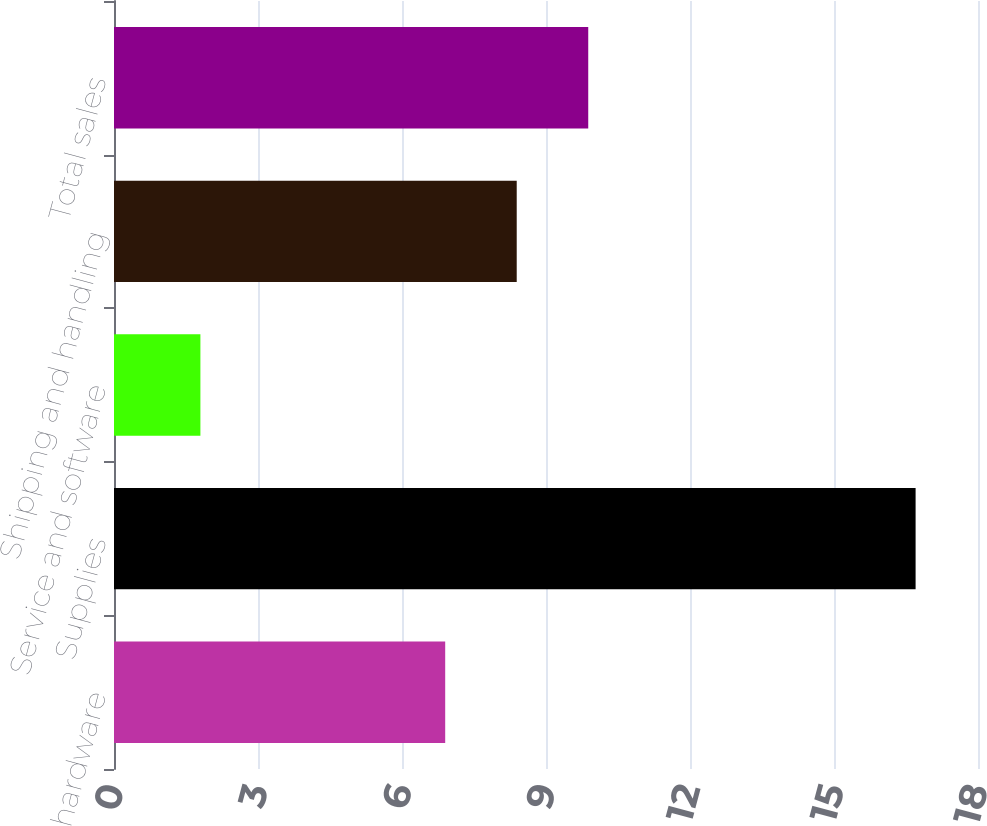Convert chart to OTSL. <chart><loc_0><loc_0><loc_500><loc_500><bar_chart><fcel>hardware<fcel>Supplies<fcel>Service and software<fcel>Shipping and handling<fcel>Total sales<nl><fcel>6.9<fcel>16.7<fcel>1.8<fcel>8.39<fcel>9.88<nl></chart> 